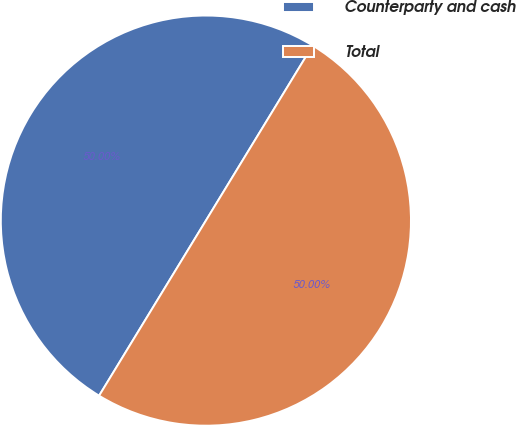Convert chart to OTSL. <chart><loc_0><loc_0><loc_500><loc_500><pie_chart><fcel>Counterparty and cash<fcel>Total<nl><fcel>50.0%<fcel>50.0%<nl></chart> 